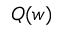<formula> <loc_0><loc_0><loc_500><loc_500>Q ( w )</formula> 